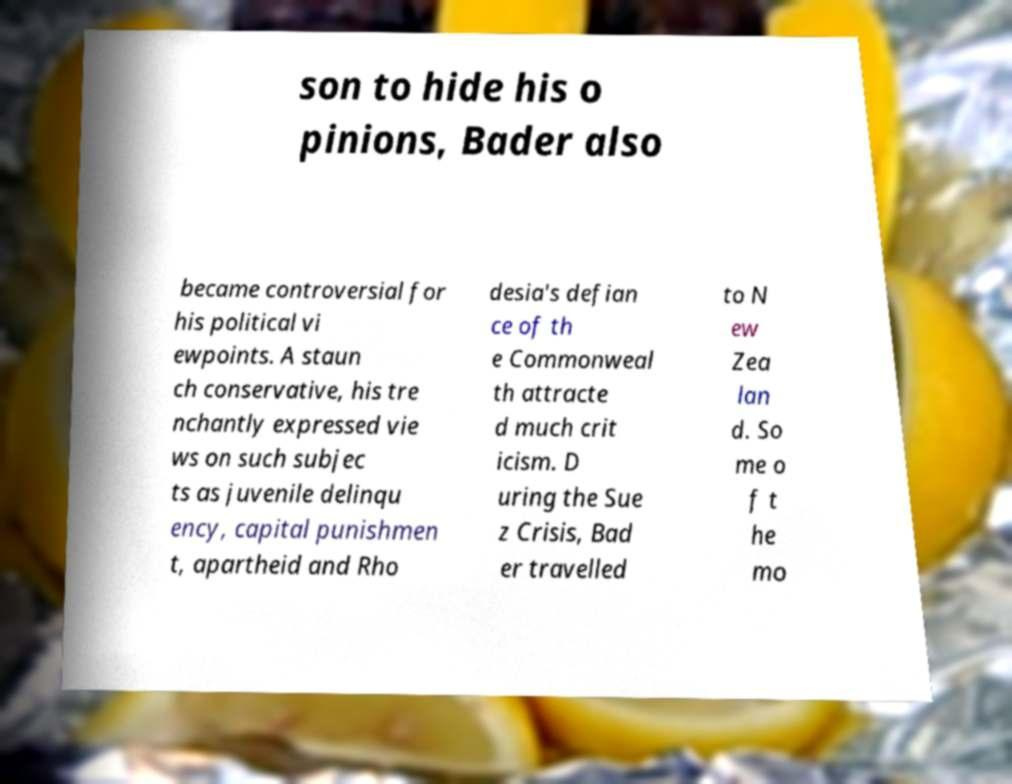Please identify and transcribe the text found in this image. son to hide his o pinions, Bader also became controversial for his political vi ewpoints. A staun ch conservative, his tre nchantly expressed vie ws on such subjec ts as juvenile delinqu ency, capital punishmen t, apartheid and Rho desia's defian ce of th e Commonweal th attracte d much crit icism. D uring the Sue z Crisis, Bad er travelled to N ew Zea lan d. So me o f t he mo 